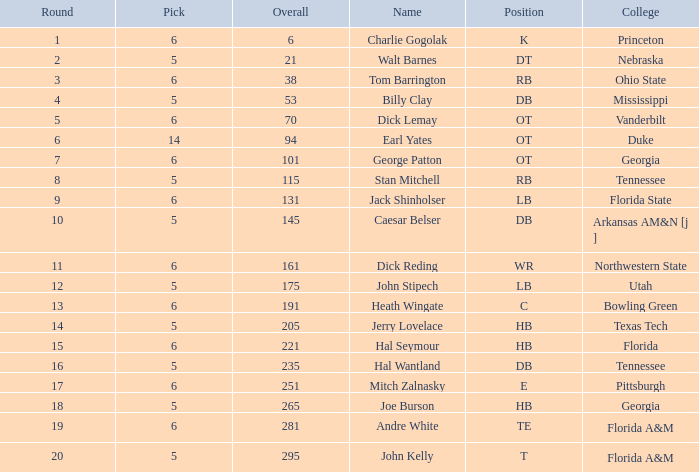What is the combined value of overall when pick is larger than 5, round falls short of 11, and name is "tom barrington"? 38.0. 